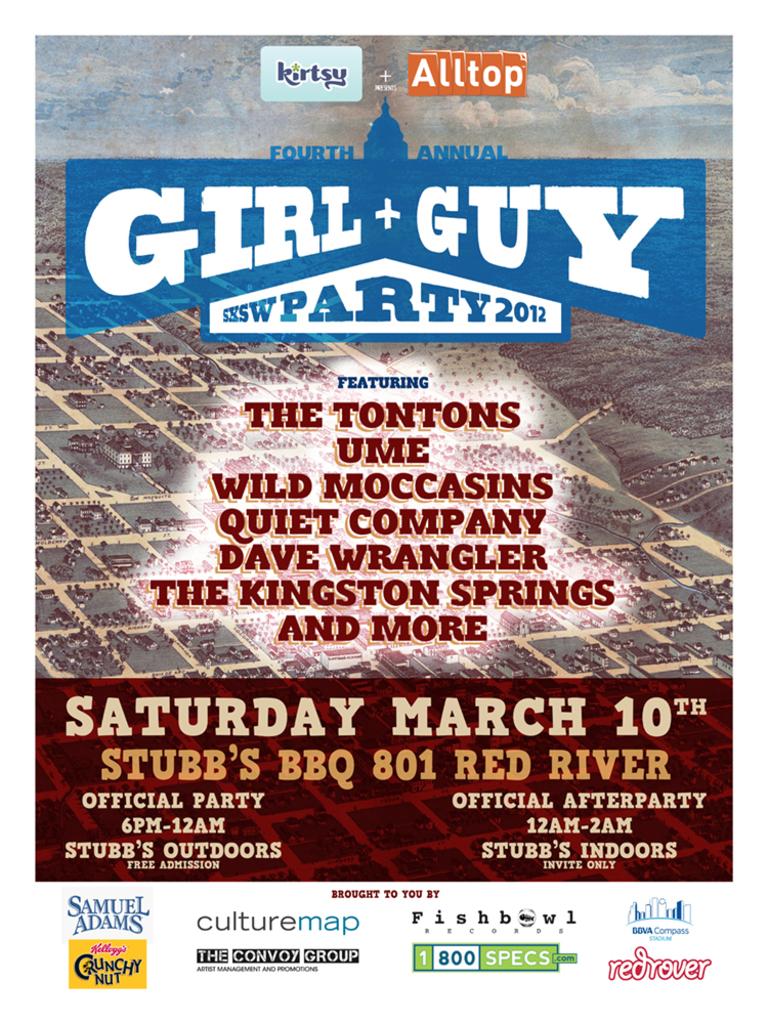What is the date of this event?
Provide a succinct answer. March 10th. 